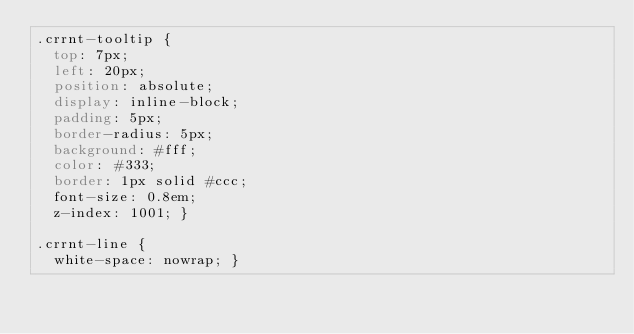Convert code to text. <code><loc_0><loc_0><loc_500><loc_500><_CSS_>.crrnt-tooltip {
  top: 7px;
  left: 20px;
  position: absolute;
  display: inline-block;
  padding: 5px;
  border-radius: 5px;
  background: #fff;
  color: #333;
  border: 1px solid #ccc;
  font-size: 0.8em;
  z-index: 1001; }

.crrnt-line {
  white-space: nowrap; }
</code> 